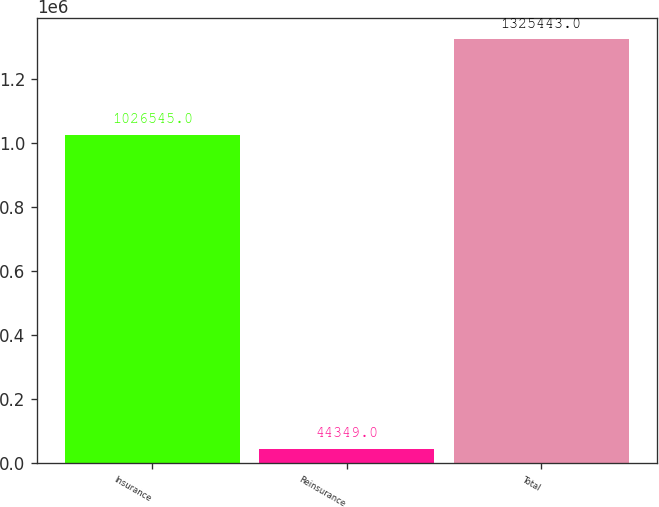Convert chart. <chart><loc_0><loc_0><loc_500><loc_500><bar_chart><fcel>Insurance<fcel>Reinsurance<fcel>Total<nl><fcel>1.02654e+06<fcel>44349<fcel>1.32544e+06<nl></chart> 